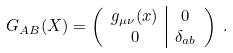Convert formula to latex. <formula><loc_0><loc_0><loc_500><loc_500>G _ { A B } ( X ) & = \left ( \begin{array} { c | c } g _ { \mu \nu } ( x ) & 0 \\ 0 & \delta _ { a b } \end{array} \right ) \ .</formula> 